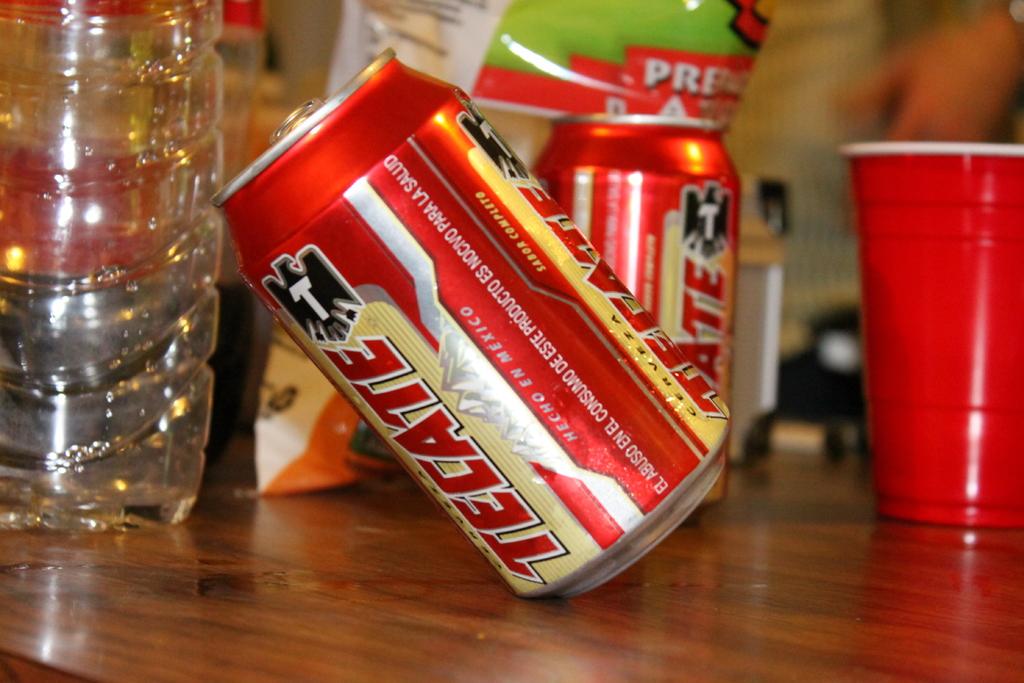Why type of beer is this?
Provide a short and direct response. Tecate. 